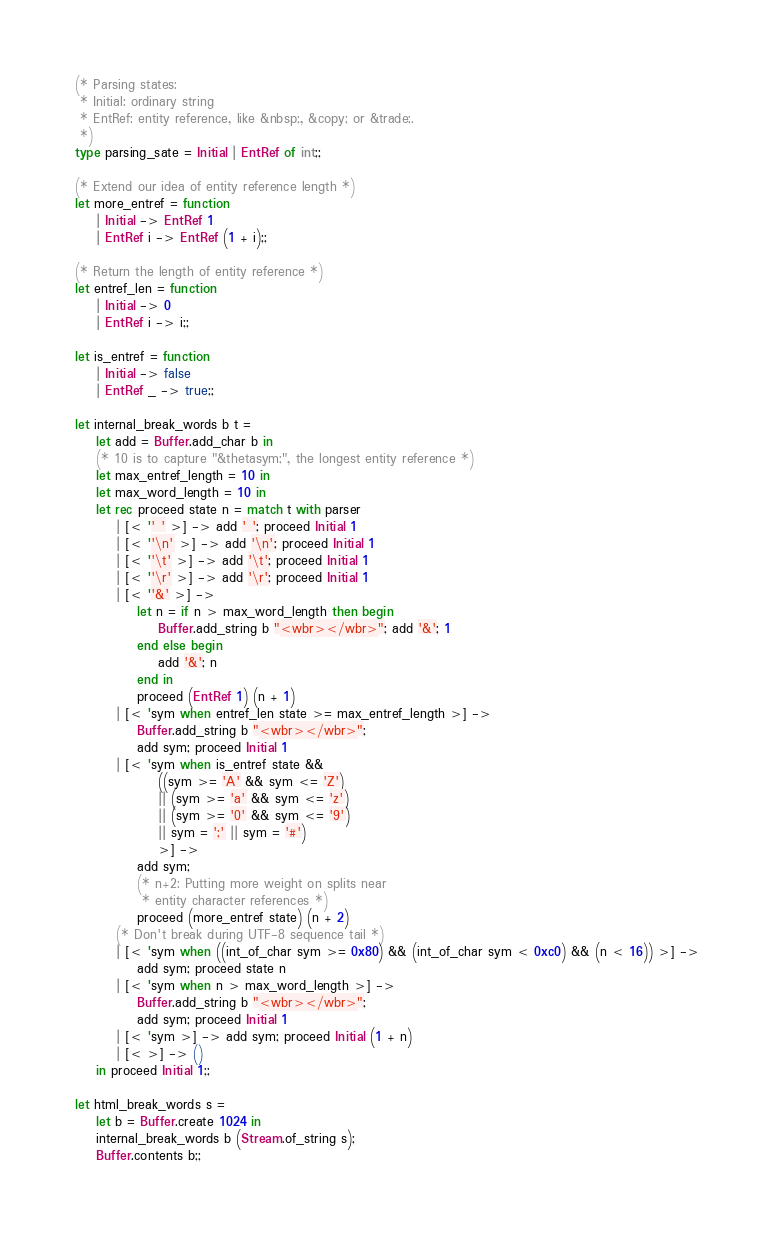<code> <loc_0><loc_0><loc_500><loc_500><_OCaml_>
(* Parsing states:
 * Initial: ordinary string
 * EntRef: entity reference, like &nbsp;, &copy; or &trade;.
 *)
type parsing_sate = Initial | EntRef of int;;

(* Extend our idea of entity reference length *)
let more_entref = function
	| Initial -> EntRef 1
	| EntRef i -> EntRef (1 + i);;

(* Return the length of entity reference *)
let entref_len = function
	| Initial -> 0
	| EntRef i -> i;;

let is_entref = function
	| Initial -> false
	| EntRef _ -> true;;

let internal_break_words b t =
	let add = Buffer.add_char b in
	(* 10 is to capture "&thetasym;", the longest entity reference *)
	let max_entref_length = 10 in
	let max_word_length = 10 in
	let rec proceed state n = match t with parser
		| [< '' ' >] -> add ' '; proceed Initial 1
		| [< ''\n' >] -> add '\n'; proceed Initial 1
		| [< ''\t' >] -> add '\t'; proceed Initial 1
		| [< ''\r' >] -> add '\r'; proceed Initial 1
		| [< ''&' >] ->
			let n = if n > max_word_length then begin
				Buffer.add_string b "<wbr></wbr>"; add '&'; 1
			end else begin
				add '&'; n
			end in
			proceed (EntRef 1) (n + 1)
		| [< 'sym when entref_len state >= max_entref_length >] ->
			Buffer.add_string b "<wbr></wbr>";
			add sym; proceed Initial 1
		| [< 'sym when is_entref state &&
				((sym >= 'A' && sym <= 'Z')
				|| (sym >= 'a' && sym <= 'z')
				|| (sym >= '0' && sym <= '9')
				|| sym = ';' || sym = '#')
				>] ->
			add sym;
			(* n+2: Putting more weight on splits near
			 * entity character references *)
			proceed (more_entref state) (n + 2)
		(* Don't break during UTF-8 sequence tail *)
		| [< 'sym when ((int_of_char sym >= 0x80) && (int_of_char sym < 0xc0) && (n < 16)) >] ->
			add sym; proceed state n
		| [< 'sym when n > max_word_length >] ->
			Buffer.add_string b "<wbr></wbr>";
			add sym; proceed Initial 1
		| [< 'sym >] -> add sym; proceed Initial (1 + n)
		| [< >] -> ()
	in proceed Initial 1;;

let html_break_words s =
	let b = Buffer.create 1024 in
	internal_break_words b (Stream.of_string s);
	Buffer.contents b;;

</code> 